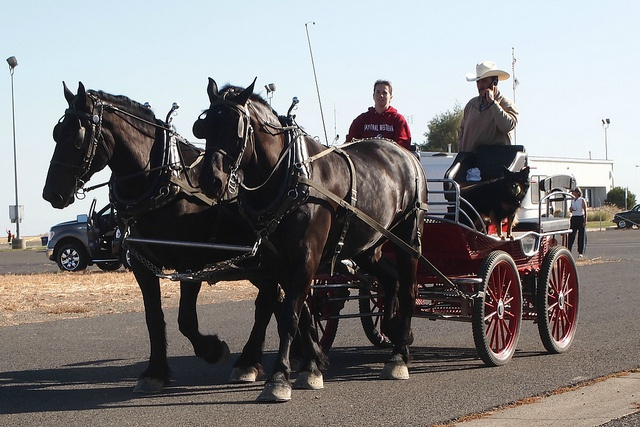Describe the objects in this image and their specific colors. I can see horse in lightblue, black, gray, and darkgray tones, horse in lightblue, black, and gray tones, truck in lightblue, black, gray, and darkgray tones, car in lightblue, black, gray, and darkgray tones, and people in lightblue, black, gray, and darkgray tones in this image. 